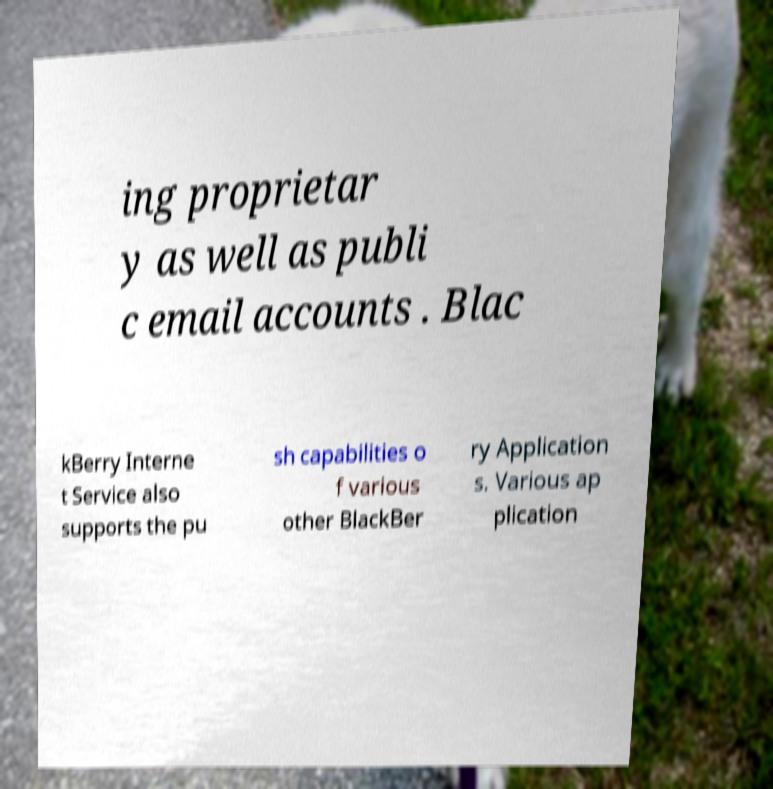Please identify and transcribe the text found in this image. ing proprietar y as well as publi c email accounts . Blac kBerry Interne t Service also supports the pu sh capabilities o f various other BlackBer ry Application s. Various ap plication 